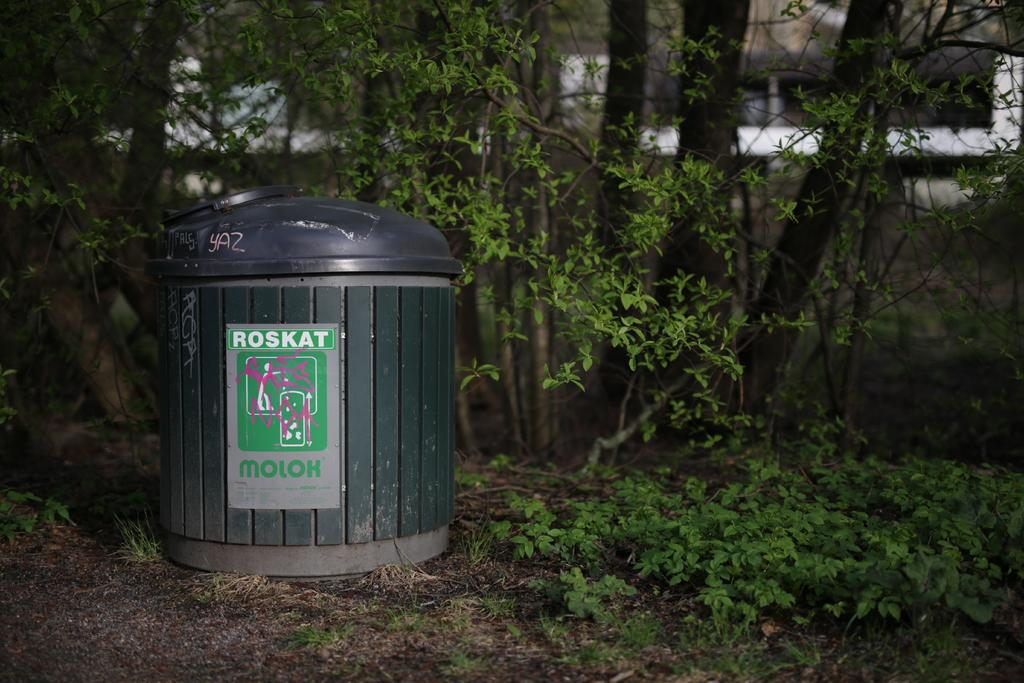Provide a one-sentence caption for the provided image. A black trash can has the word Roskat in block white lettering. 